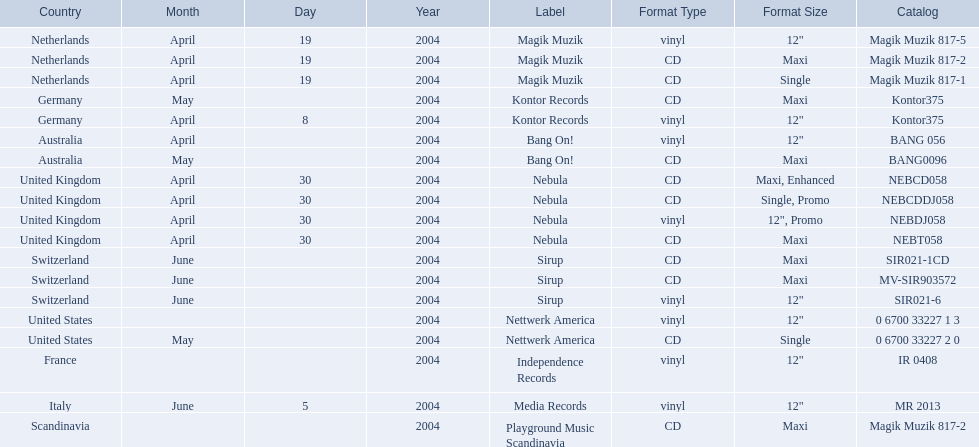What are all of the regions the title was released in? Netherlands, Netherlands, Netherlands, Germany, Germany, Australia, Australia, United Kingdom, United Kingdom, United Kingdom, United Kingdom, Switzerland, Switzerland, Switzerland, United States, United States, France, Italy, Scandinavia. And under which labels were they released? Magik Muzik, Magik Muzik, Magik Muzik, Kontor Records, Kontor Records, Bang On!, Bang On!, Nebula, Nebula, Nebula, Nebula, Sirup, Sirup, Sirup, Nettwerk America, Nettwerk America, Independence Records, Media Records, Playground Music Scandinavia. Which label released the song in france? Independence Records. 